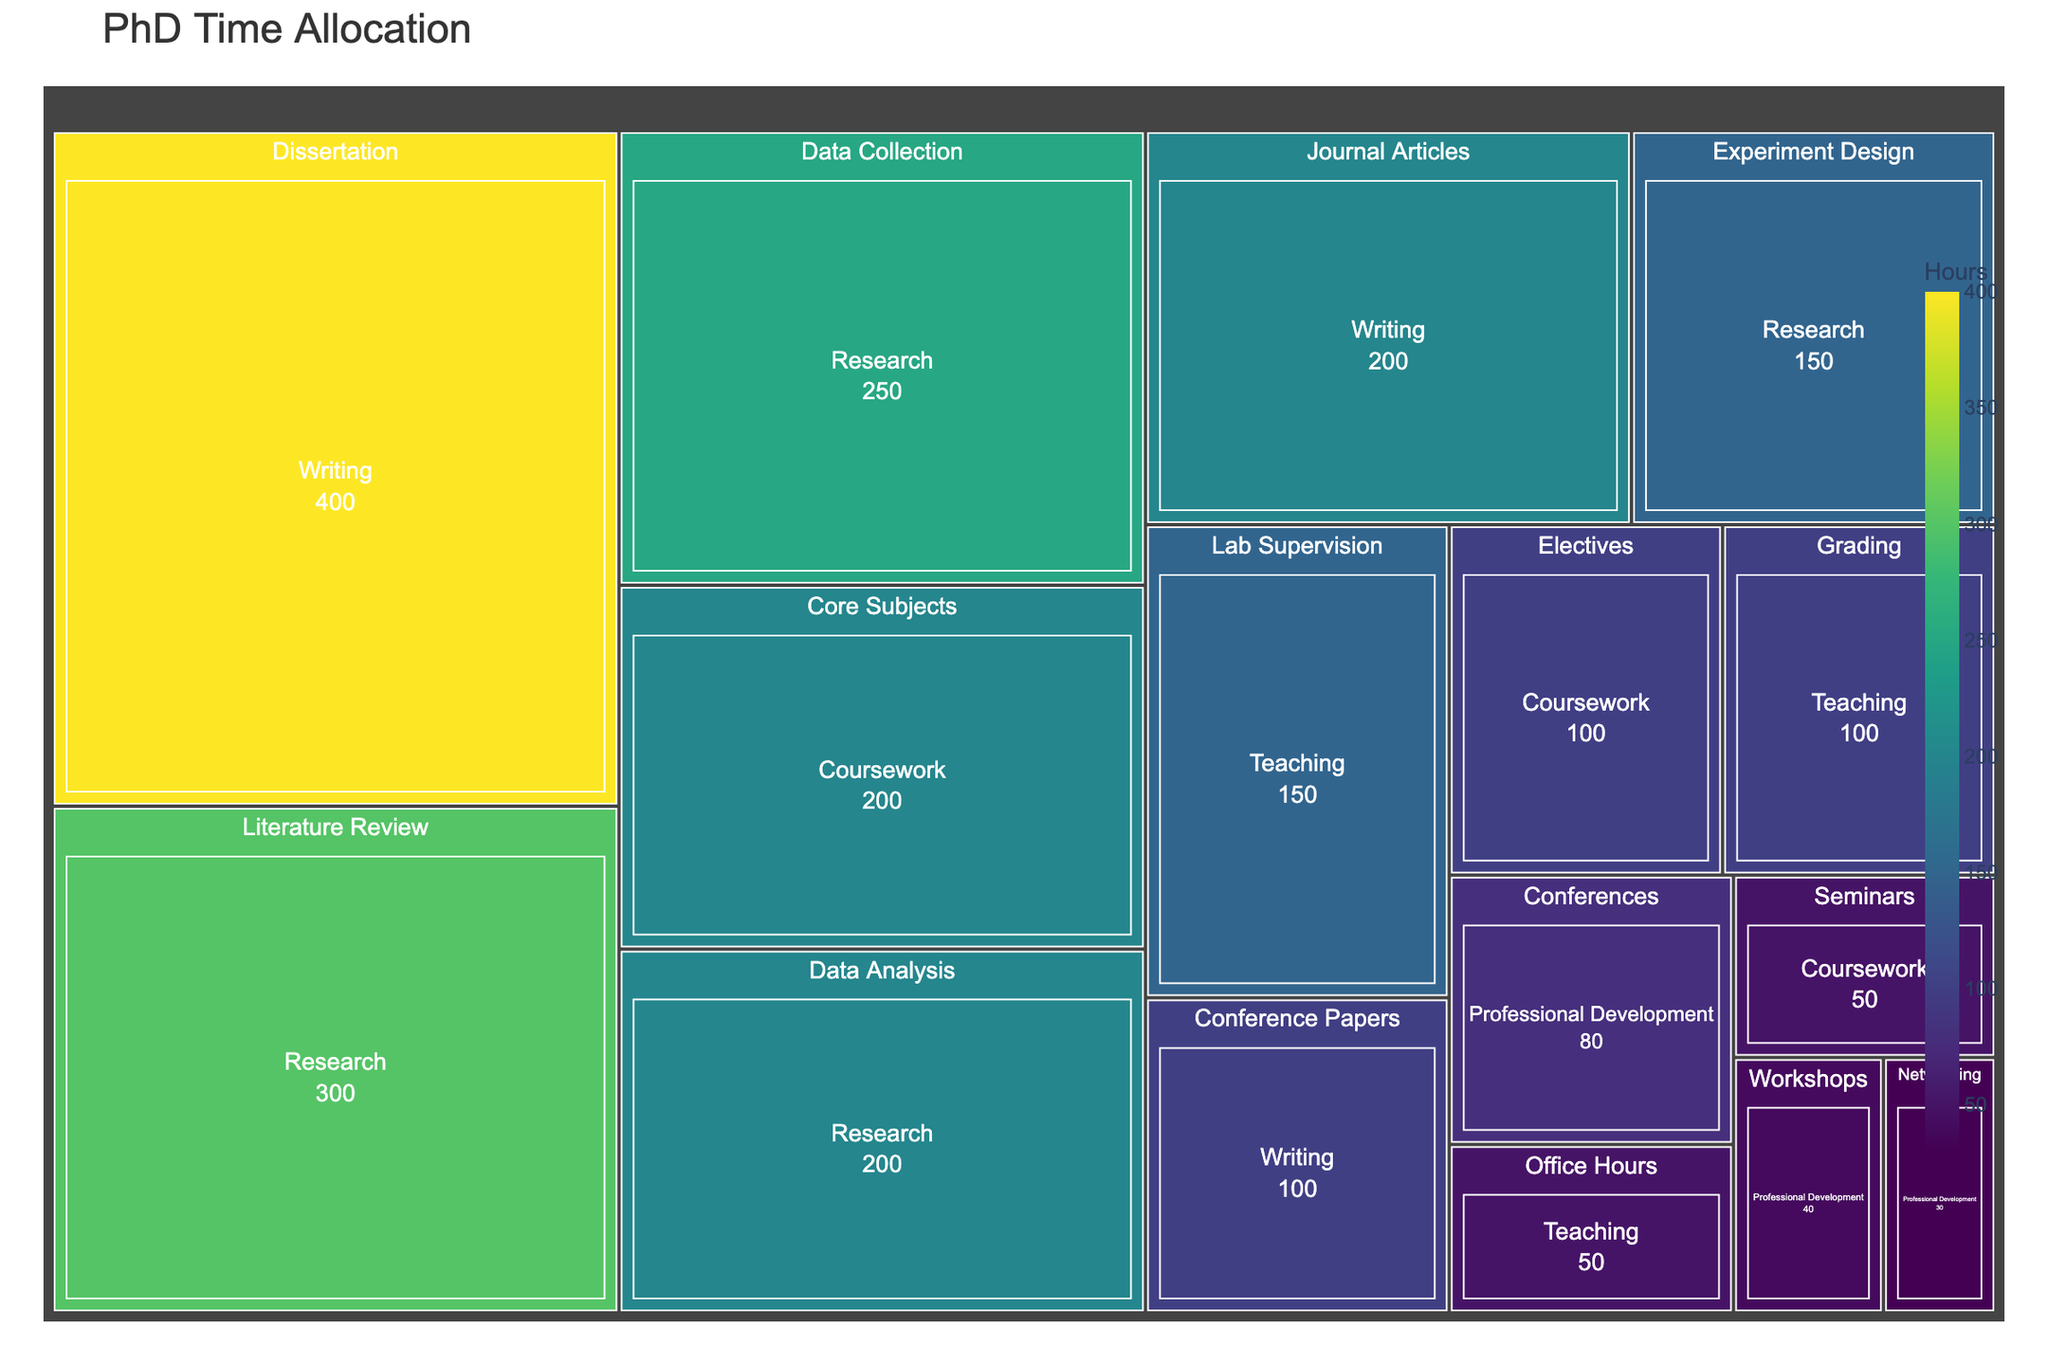What's the title of the figure? The title is usually at the top of the figure and indicates the main topic the visual represents. From our description, the title is "PhD Time Allocation."
Answer: PhD Time Allocation Which specific activity within "Writing" consumes the most hours? Look for the category "Writing" and identify the activity with the largest value. In this case, it's the "Dissertation" with 400 hours.
Answer: Dissertation How many hours are allocated to "Teaching" in total? Add up the hours of all activities under the category "Teaching." Adding 150 (Lab Supervision) + 100 (Grading) + 50 (Office Hours) gives a total of 300 hours.
Answer: 300 Which activity has the least amount of hours allocated across all categories? Scan the entire Treemap and find the activity with the smallest value. "Networking" under "Professional Development" has only 30 hours.
Answer: Networking How does the total time spent on "Research" compare to "Coursework"? Sum the hours spent on each activity under "Research" and "Coursework", then compare the totals. Research: 300 + 250 + 200 + 150 = 900 Coursework: 200 + 100 + 50 = 350 So, time spent on Research is significantly higher.
Answer: Research: 900, Coursework: 350 What's the average number of hours allocated per activity within "Professional Development"? Add up the hours for all activities under "Professional Development" and divide by the number of activities. Total hours: 80 + 40 + 30 = 150. There are 3 activities, so the average is 150 / 3.
Answer: 50 Is the time spent on "Grading" more, less, or equal to the time spent on "Conference Papers"? Compare the hours allocated to "Grading" (100) with "Conference Papers" (100). Both have 100 hours allocated.
Answer: Equal Which category has the most diverse set of activities based on the number of subcategories? Count the number of subcategories within each main category. "Research" has the most diverse set with 4 activities (Literature Review, Data Collection, Data Analysis, Experiment Design).
Answer: Research What is the combined time allocation for "Data Collection" and "Data Analysis" activities? Add the hours for "Data Collection" and "Data Analysis" under the "Research" category. Data Collection: 250, Data Analysis: 200 Total is 250 + 200.
Answer: 450 